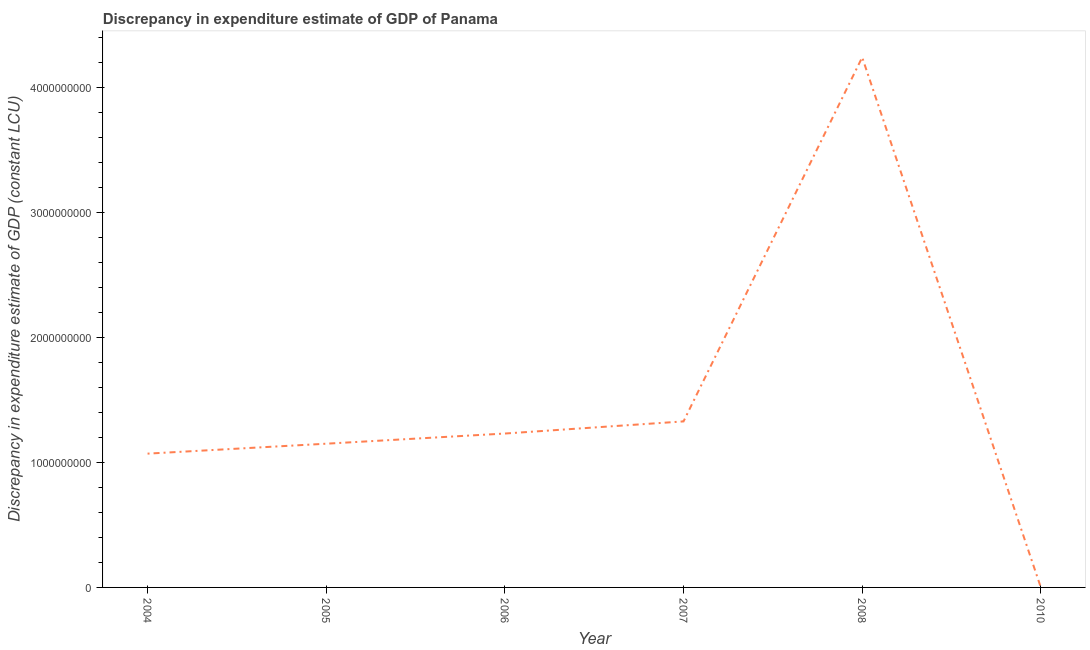What is the discrepancy in expenditure estimate of gdp in 2004?
Make the answer very short. 1.07e+09. Across all years, what is the maximum discrepancy in expenditure estimate of gdp?
Give a very brief answer. 4.24e+09. Across all years, what is the minimum discrepancy in expenditure estimate of gdp?
Provide a short and direct response. 0. In which year was the discrepancy in expenditure estimate of gdp maximum?
Your response must be concise. 2008. What is the sum of the discrepancy in expenditure estimate of gdp?
Your response must be concise. 9.02e+09. What is the difference between the discrepancy in expenditure estimate of gdp in 2004 and 2005?
Your answer should be compact. -7.95e+07. What is the average discrepancy in expenditure estimate of gdp per year?
Offer a terse response. 1.50e+09. What is the median discrepancy in expenditure estimate of gdp?
Offer a very short reply. 1.19e+09. In how many years, is the discrepancy in expenditure estimate of gdp greater than 200000000 LCU?
Offer a very short reply. 5. What is the ratio of the discrepancy in expenditure estimate of gdp in 2005 to that in 2006?
Make the answer very short. 0.93. Is the difference between the discrepancy in expenditure estimate of gdp in 2007 and 2008 greater than the difference between any two years?
Your response must be concise. No. What is the difference between the highest and the second highest discrepancy in expenditure estimate of gdp?
Offer a terse response. 2.91e+09. Is the sum of the discrepancy in expenditure estimate of gdp in 2004 and 2006 greater than the maximum discrepancy in expenditure estimate of gdp across all years?
Ensure brevity in your answer.  No. What is the difference between the highest and the lowest discrepancy in expenditure estimate of gdp?
Your answer should be compact. 4.24e+09. In how many years, is the discrepancy in expenditure estimate of gdp greater than the average discrepancy in expenditure estimate of gdp taken over all years?
Make the answer very short. 1. How many lines are there?
Offer a terse response. 1. How many years are there in the graph?
Offer a very short reply. 6. Are the values on the major ticks of Y-axis written in scientific E-notation?
Ensure brevity in your answer.  No. Does the graph contain any zero values?
Ensure brevity in your answer.  Yes. Does the graph contain grids?
Keep it short and to the point. No. What is the title of the graph?
Offer a very short reply. Discrepancy in expenditure estimate of GDP of Panama. What is the label or title of the X-axis?
Your answer should be very brief. Year. What is the label or title of the Y-axis?
Provide a succinct answer. Discrepancy in expenditure estimate of GDP (constant LCU). What is the Discrepancy in expenditure estimate of GDP (constant LCU) in 2004?
Offer a terse response. 1.07e+09. What is the Discrepancy in expenditure estimate of GDP (constant LCU) of 2005?
Keep it short and to the point. 1.15e+09. What is the Discrepancy in expenditure estimate of GDP (constant LCU) of 2006?
Keep it short and to the point. 1.23e+09. What is the Discrepancy in expenditure estimate of GDP (constant LCU) in 2007?
Your response must be concise. 1.33e+09. What is the Discrepancy in expenditure estimate of GDP (constant LCU) in 2008?
Ensure brevity in your answer.  4.24e+09. What is the Discrepancy in expenditure estimate of GDP (constant LCU) in 2010?
Offer a terse response. 0. What is the difference between the Discrepancy in expenditure estimate of GDP (constant LCU) in 2004 and 2005?
Keep it short and to the point. -7.95e+07. What is the difference between the Discrepancy in expenditure estimate of GDP (constant LCU) in 2004 and 2006?
Offer a very short reply. -1.61e+08. What is the difference between the Discrepancy in expenditure estimate of GDP (constant LCU) in 2004 and 2007?
Your answer should be compact. -2.58e+08. What is the difference between the Discrepancy in expenditure estimate of GDP (constant LCU) in 2004 and 2008?
Your response must be concise. -3.17e+09. What is the difference between the Discrepancy in expenditure estimate of GDP (constant LCU) in 2005 and 2006?
Offer a very short reply. -8.14e+07. What is the difference between the Discrepancy in expenditure estimate of GDP (constant LCU) in 2005 and 2007?
Your answer should be very brief. -1.78e+08. What is the difference between the Discrepancy in expenditure estimate of GDP (constant LCU) in 2005 and 2008?
Your response must be concise. -3.09e+09. What is the difference between the Discrepancy in expenditure estimate of GDP (constant LCU) in 2006 and 2007?
Make the answer very short. -9.70e+07. What is the difference between the Discrepancy in expenditure estimate of GDP (constant LCU) in 2006 and 2008?
Keep it short and to the point. -3.01e+09. What is the difference between the Discrepancy in expenditure estimate of GDP (constant LCU) in 2007 and 2008?
Offer a terse response. -2.91e+09. What is the ratio of the Discrepancy in expenditure estimate of GDP (constant LCU) in 2004 to that in 2005?
Provide a short and direct response. 0.93. What is the ratio of the Discrepancy in expenditure estimate of GDP (constant LCU) in 2004 to that in 2006?
Make the answer very short. 0.87. What is the ratio of the Discrepancy in expenditure estimate of GDP (constant LCU) in 2004 to that in 2007?
Offer a terse response. 0.81. What is the ratio of the Discrepancy in expenditure estimate of GDP (constant LCU) in 2004 to that in 2008?
Your answer should be compact. 0.25. What is the ratio of the Discrepancy in expenditure estimate of GDP (constant LCU) in 2005 to that in 2006?
Keep it short and to the point. 0.93. What is the ratio of the Discrepancy in expenditure estimate of GDP (constant LCU) in 2005 to that in 2007?
Offer a terse response. 0.87. What is the ratio of the Discrepancy in expenditure estimate of GDP (constant LCU) in 2005 to that in 2008?
Your response must be concise. 0.27. What is the ratio of the Discrepancy in expenditure estimate of GDP (constant LCU) in 2006 to that in 2007?
Keep it short and to the point. 0.93. What is the ratio of the Discrepancy in expenditure estimate of GDP (constant LCU) in 2006 to that in 2008?
Offer a very short reply. 0.29. What is the ratio of the Discrepancy in expenditure estimate of GDP (constant LCU) in 2007 to that in 2008?
Ensure brevity in your answer.  0.31. 